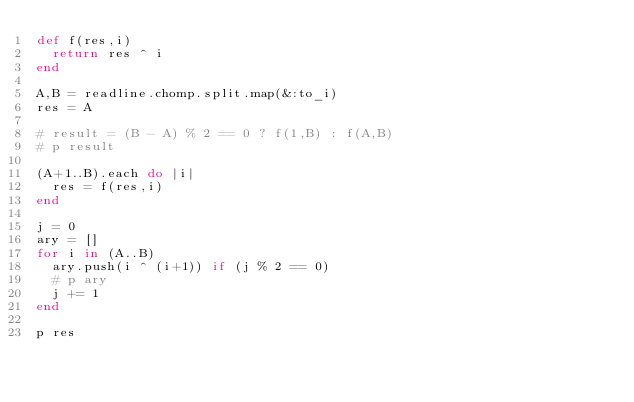<code> <loc_0><loc_0><loc_500><loc_500><_Ruby_>def f(res,i)
  return res ^ i
end

A,B = readline.chomp.split.map(&:to_i)
res = A

# result = (B - A) % 2 == 0 ? f(1,B) : f(A,B)
# p result

(A+1..B).each do |i|
  res = f(res,i)
end

j = 0
ary = []
for i in (A..B)
  ary.push(i ^ (i+1)) if (j % 2 == 0)
  # p ary
  j += 1
end

p res</code> 